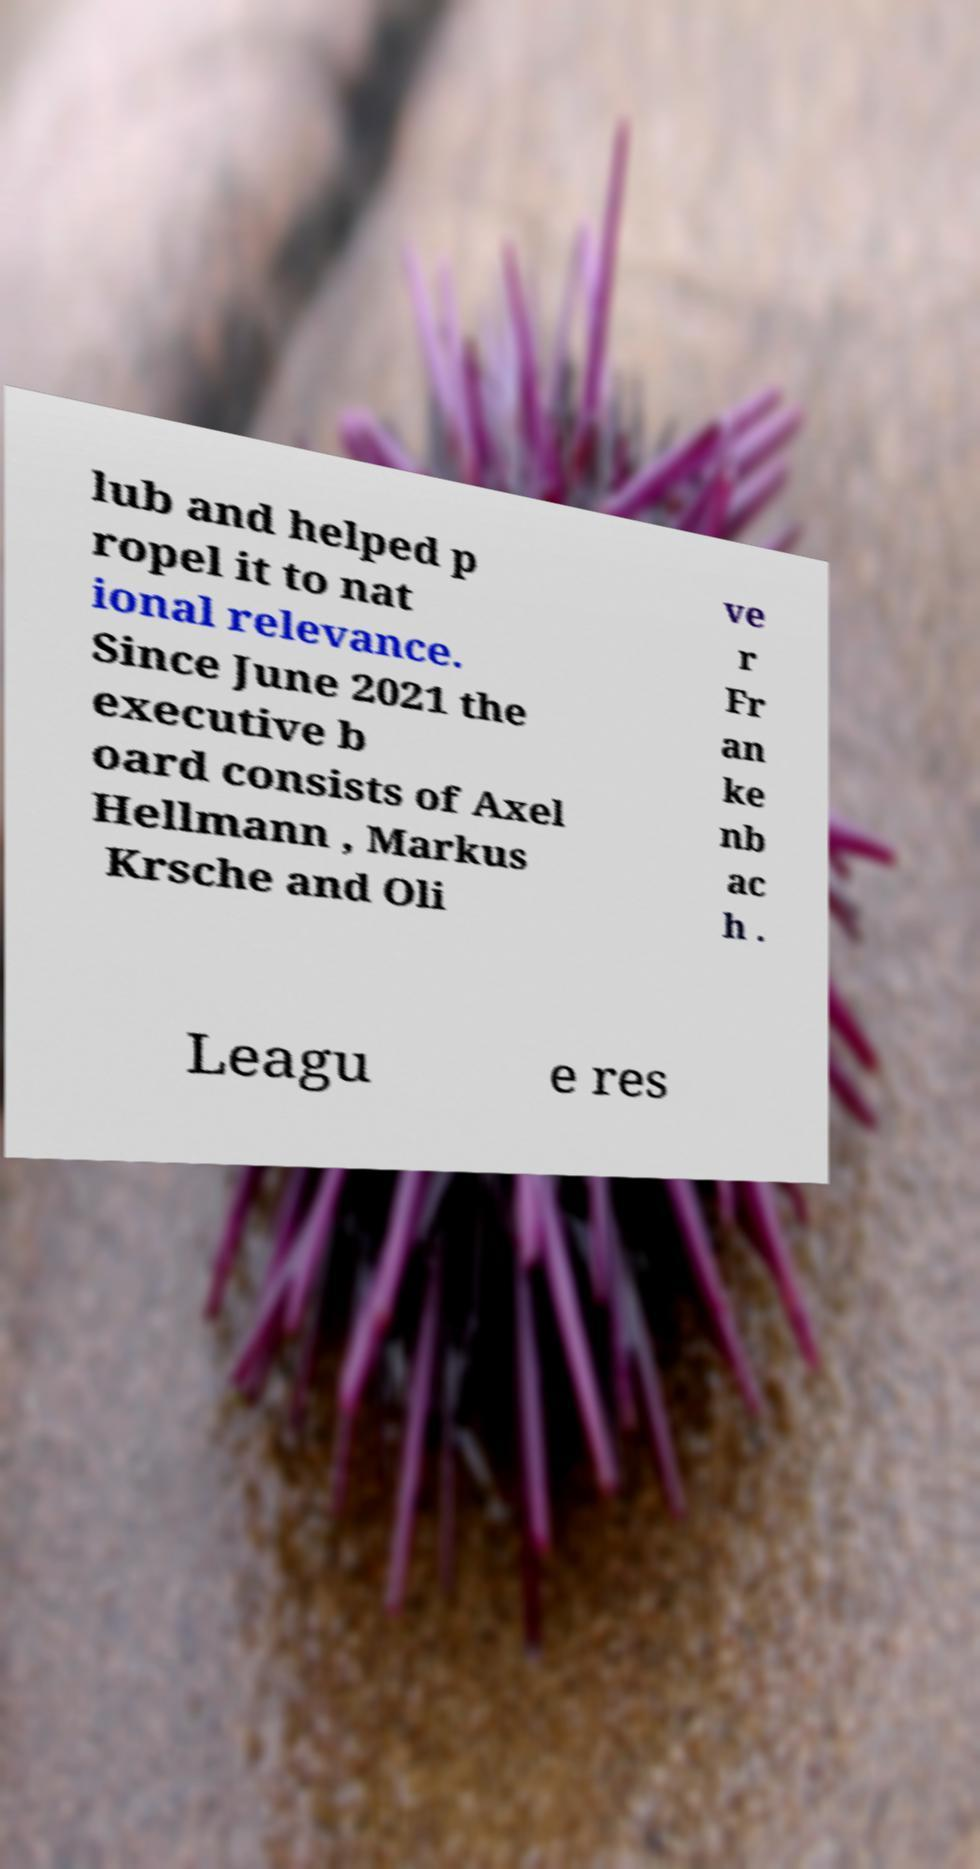What messages or text are displayed in this image? I need them in a readable, typed format. lub and helped p ropel it to nat ional relevance. Since June 2021 the executive b oard consists of Axel Hellmann , Markus Krsche and Oli ve r Fr an ke nb ac h . Leagu e res 